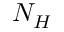<formula> <loc_0><loc_0><loc_500><loc_500>N _ { H }</formula> 